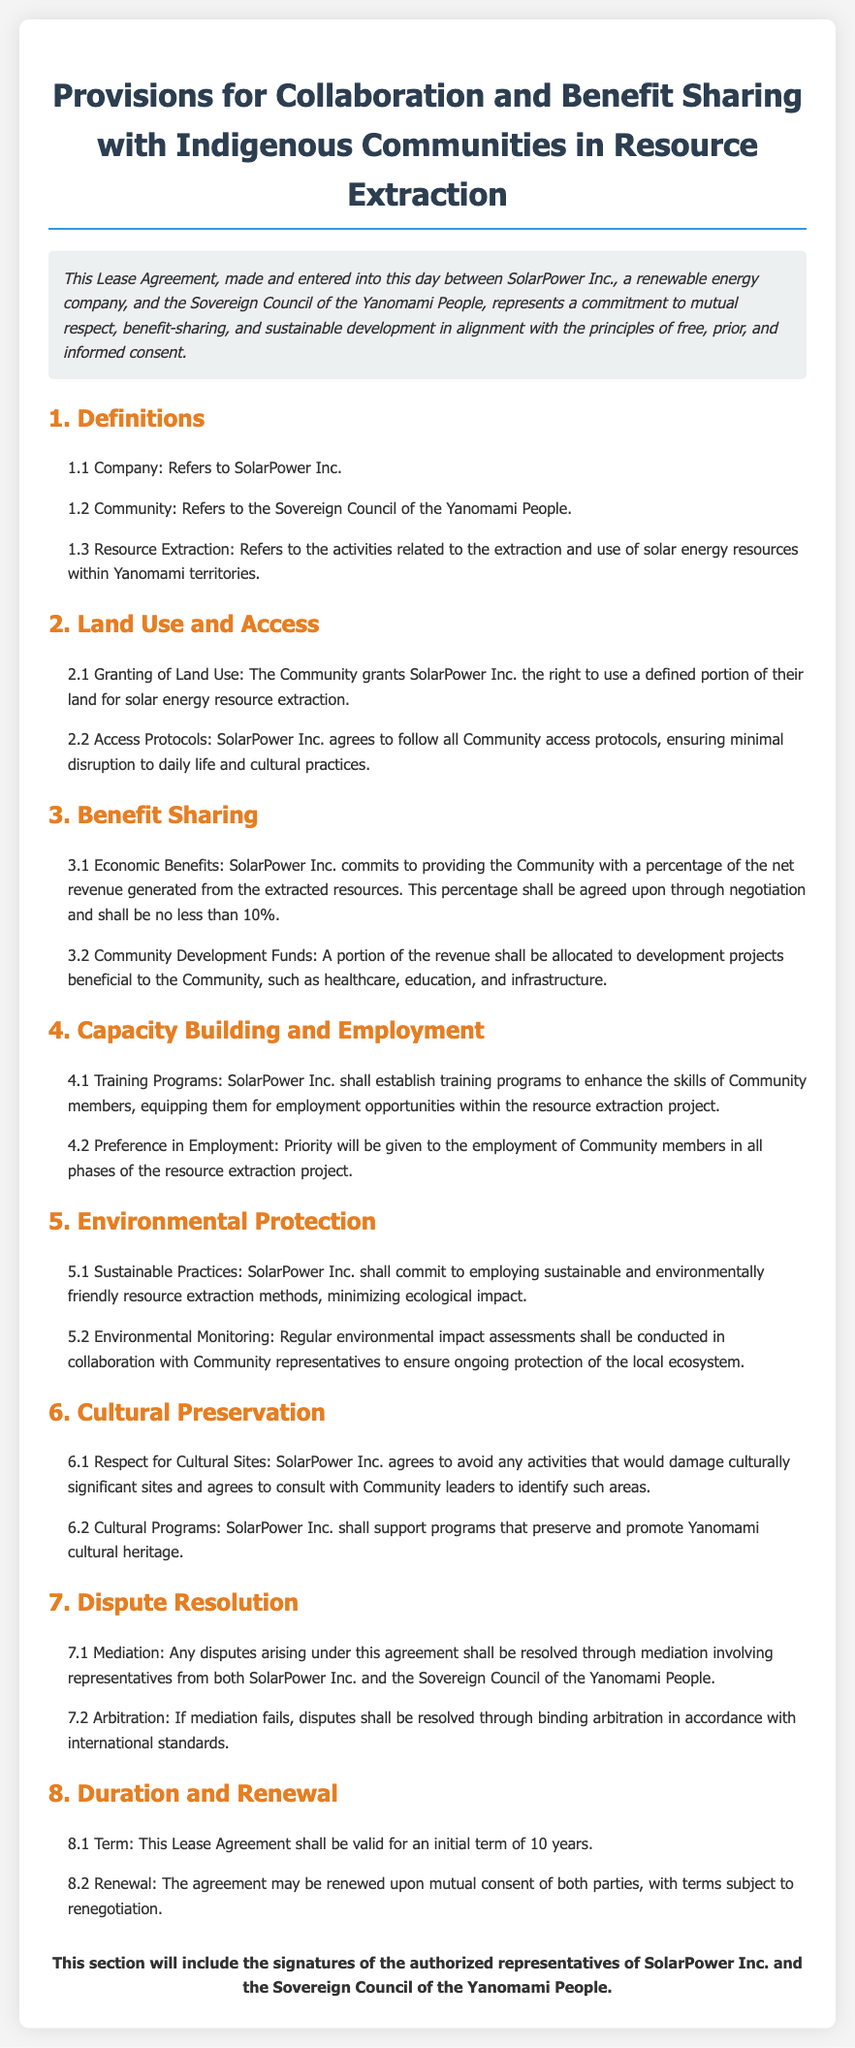what is the name of the company? The document states that the company involved is SolarPower Inc.
Answer: SolarPower Inc who are the community representatives? The document refers to the representatives as the Sovereign Council of the Yanomami People.
Answer: Sovereign Council of the Yanomami People what is the percentage of net revenue guaranteed to the community? The document specifies that the percentage shall be no less than 10%.
Answer: 10% how long is the initial term of the lease agreement? The document clearly states that the initial term of the lease agreement is 10 years.
Answer: 10 years what must SolarPower Inc. follow according to access protocols? The access protocols must ensure minimal disruption to daily life and cultural practices of the Community.
Answer: minimal disruption to daily life and cultural practices which training programs will be established? The document indicates that training programs will enhance the skills of Community members for resource extraction employment.
Answer: enhance the skills of Community members what happens if mediation fails? According to the document, if mediation fails, disputes shall be resolved through binding arbitration.
Answer: binding arbitration what area does the resource extraction relate to? The document states that resource extraction relates to the activities within Yanomami territories.
Answer: Yanomami territories how will environmental protection be monitored? The document mentions that regular environmental impact assessments will be conducted in collaboration with Community representatives.
Answer: collaboration with Community representatives 